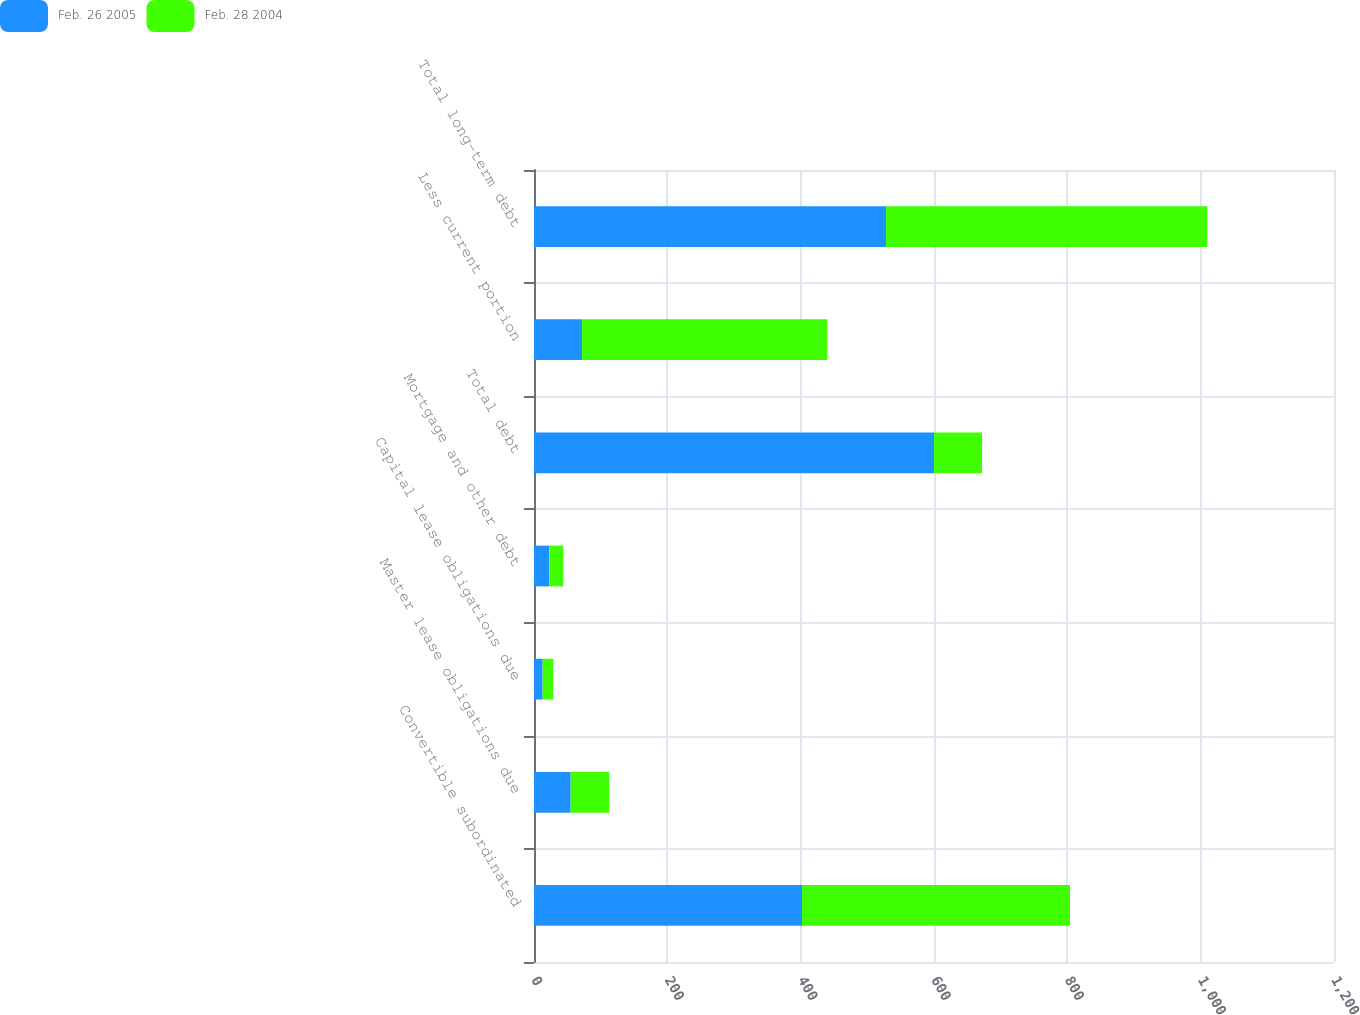Convert chart. <chart><loc_0><loc_0><loc_500><loc_500><stacked_bar_chart><ecel><fcel>Convertible subordinated<fcel>Master lease obligations due<fcel>Capital lease obligations due<fcel>Mortgage and other debt<fcel>Total debt<fcel>Less current portion<fcel>Total long-term debt<nl><fcel>Feb. 26 2005<fcel>402<fcel>55<fcel>13<fcel>23<fcel>600<fcel>72<fcel>528<nl><fcel>Feb. 28 2004<fcel>402<fcel>58<fcel>16<fcel>21<fcel>72<fcel>368<fcel>482<nl></chart> 